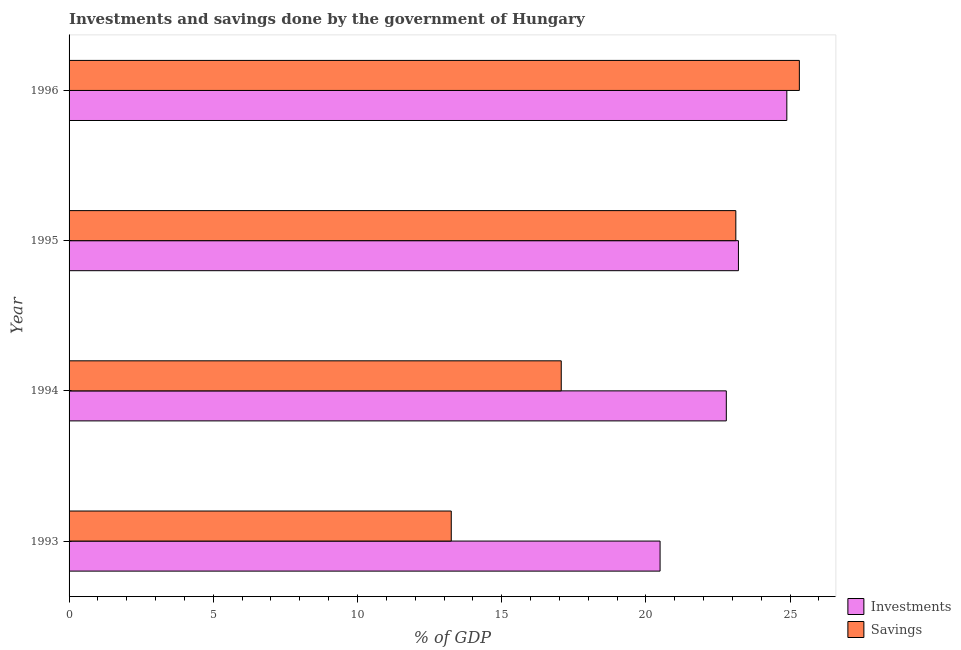How many different coloured bars are there?
Make the answer very short. 2. How many groups of bars are there?
Your response must be concise. 4. Are the number of bars per tick equal to the number of legend labels?
Provide a succinct answer. Yes. Are the number of bars on each tick of the Y-axis equal?
Your response must be concise. Yes. How many bars are there on the 2nd tick from the bottom?
Your answer should be very brief. 2. In how many cases, is the number of bars for a given year not equal to the number of legend labels?
Your response must be concise. 0. What is the investments of government in 1995?
Your response must be concise. 23.21. Across all years, what is the maximum savings of government?
Keep it short and to the point. 25.32. Across all years, what is the minimum investments of government?
Your answer should be compact. 20.49. What is the total savings of government in the graph?
Your answer should be compact. 78.75. What is the difference between the investments of government in 1995 and that in 1996?
Your response must be concise. -1.68. What is the difference between the investments of government in 1995 and the savings of government in 1993?
Your answer should be compact. 9.96. What is the average investments of government per year?
Offer a very short reply. 22.84. In the year 1995, what is the difference between the investments of government and savings of government?
Your response must be concise. 0.09. What is the ratio of the savings of government in 1993 to that in 1996?
Provide a short and direct response. 0.52. Is the investments of government in 1994 less than that in 1996?
Your response must be concise. Yes. What is the difference between the highest and the second highest investments of government?
Offer a very short reply. 1.68. What is the difference between the highest and the lowest investments of government?
Provide a short and direct response. 4.39. What does the 2nd bar from the top in 1993 represents?
Your response must be concise. Investments. What does the 2nd bar from the bottom in 1993 represents?
Give a very brief answer. Savings. What is the difference between two consecutive major ticks on the X-axis?
Your answer should be compact. 5. Are the values on the major ticks of X-axis written in scientific E-notation?
Ensure brevity in your answer.  No. Does the graph contain any zero values?
Your response must be concise. No. How many legend labels are there?
Give a very brief answer. 2. What is the title of the graph?
Keep it short and to the point. Investments and savings done by the government of Hungary. Does "Old" appear as one of the legend labels in the graph?
Your answer should be very brief. No. What is the label or title of the X-axis?
Ensure brevity in your answer.  % of GDP. What is the label or title of the Y-axis?
Provide a succinct answer. Year. What is the % of GDP of Investments in 1993?
Ensure brevity in your answer.  20.49. What is the % of GDP of Savings in 1993?
Keep it short and to the point. 13.25. What is the % of GDP of Investments in 1994?
Your response must be concise. 22.79. What is the % of GDP of Savings in 1994?
Your response must be concise. 17.06. What is the % of GDP of Investments in 1995?
Your answer should be very brief. 23.21. What is the % of GDP of Savings in 1995?
Keep it short and to the point. 23.12. What is the % of GDP of Investments in 1996?
Your answer should be very brief. 24.89. What is the % of GDP in Savings in 1996?
Give a very brief answer. 25.32. Across all years, what is the maximum % of GDP in Investments?
Your answer should be compact. 24.89. Across all years, what is the maximum % of GDP in Savings?
Provide a succinct answer. 25.32. Across all years, what is the minimum % of GDP of Investments?
Offer a terse response. 20.49. Across all years, what is the minimum % of GDP in Savings?
Provide a succinct answer. 13.25. What is the total % of GDP in Investments in the graph?
Keep it short and to the point. 91.37. What is the total % of GDP in Savings in the graph?
Offer a very short reply. 78.75. What is the difference between the % of GDP of Investments in 1993 and that in 1994?
Your answer should be very brief. -2.3. What is the difference between the % of GDP of Savings in 1993 and that in 1994?
Keep it short and to the point. -3.81. What is the difference between the % of GDP of Investments in 1993 and that in 1995?
Provide a succinct answer. -2.72. What is the difference between the % of GDP in Savings in 1993 and that in 1995?
Your response must be concise. -9.87. What is the difference between the % of GDP of Investments in 1993 and that in 1996?
Your response must be concise. -4.39. What is the difference between the % of GDP of Savings in 1993 and that in 1996?
Give a very brief answer. -12.07. What is the difference between the % of GDP in Investments in 1994 and that in 1995?
Keep it short and to the point. -0.42. What is the difference between the % of GDP in Savings in 1994 and that in 1995?
Offer a very short reply. -6.05. What is the difference between the % of GDP of Investments in 1994 and that in 1996?
Your answer should be very brief. -2.1. What is the difference between the % of GDP of Savings in 1994 and that in 1996?
Provide a short and direct response. -8.26. What is the difference between the % of GDP in Investments in 1995 and that in 1996?
Your answer should be compact. -1.68. What is the difference between the % of GDP of Savings in 1995 and that in 1996?
Give a very brief answer. -2.2. What is the difference between the % of GDP of Investments in 1993 and the % of GDP of Savings in 1994?
Ensure brevity in your answer.  3.43. What is the difference between the % of GDP of Investments in 1993 and the % of GDP of Savings in 1995?
Offer a very short reply. -2.63. What is the difference between the % of GDP in Investments in 1993 and the % of GDP in Savings in 1996?
Provide a succinct answer. -4.83. What is the difference between the % of GDP in Investments in 1994 and the % of GDP in Savings in 1995?
Your answer should be very brief. -0.33. What is the difference between the % of GDP in Investments in 1994 and the % of GDP in Savings in 1996?
Your answer should be compact. -2.53. What is the difference between the % of GDP in Investments in 1995 and the % of GDP in Savings in 1996?
Give a very brief answer. -2.11. What is the average % of GDP in Investments per year?
Keep it short and to the point. 22.84. What is the average % of GDP in Savings per year?
Keep it short and to the point. 19.69. In the year 1993, what is the difference between the % of GDP of Investments and % of GDP of Savings?
Your response must be concise. 7.24. In the year 1994, what is the difference between the % of GDP in Investments and % of GDP in Savings?
Make the answer very short. 5.72. In the year 1995, what is the difference between the % of GDP in Investments and % of GDP in Savings?
Offer a terse response. 0.09. In the year 1996, what is the difference between the % of GDP of Investments and % of GDP of Savings?
Your response must be concise. -0.43. What is the ratio of the % of GDP in Investments in 1993 to that in 1994?
Your answer should be compact. 0.9. What is the ratio of the % of GDP in Savings in 1993 to that in 1994?
Offer a terse response. 0.78. What is the ratio of the % of GDP of Investments in 1993 to that in 1995?
Provide a succinct answer. 0.88. What is the ratio of the % of GDP in Savings in 1993 to that in 1995?
Offer a terse response. 0.57. What is the ratio of the % of GDP of Investments in 1993 to that in 1996?
Your response must be concise. 0.82. What is the ratio of the % of GDP of Savings in 1993 to that in 1996?
Offer a very short reply. 0.52. What is the ratio of the % of GDP in Investments in 1994 to that in 1995?
Your response must be concise. 0.98. What is the ratio of the % of GDP in Savings in 1994 to that in 1995?
Provide a succinct answer. 0.74. What is the ratio of the % of GDP of Investments in 1994 to that in 1996?
Your response must be concise. 0.92. What is the ratio of the % of GDP in Savings in 1994 to that in 1996?
Your answer should be very brief. 0.67. What is the ratio of the % of GDP in Investments in 1995 to that in 1996?
Provide a short and direct response. 0.93. What is the ratio of the % of GDP of Savings in 1995 to that in 1996?
Your answer should be compact. 0.91. What is the difference between the highest and the second highest % of GDP in Investments?
Provide a short and direct response. 1.68. What is the difference between the highest and the second highest % of GDP of Savings?
Offer a terse response. 2.2. What is the difference between the highest and the lowest % of GDP in Investments?
Provide a short and direct response. 4.39. What is the difference between the highest and the lowest % of GDP in Savings?
Your response must be concise. 12.07. 